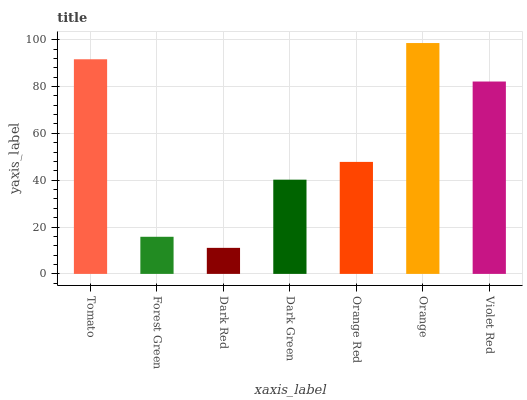Is Dark Red the minimum?
Answer yes or no. Yes. Is Orange the maximum?
Answer yes or no. Yes. Is Forest Green the minimum?
Answer yes or no. No. Is Forest Green the maximum?
Answer yes or no. No. Is Tomato greater than Forest Green?
Answer yes or no. Yes. Is Forest Green less than Tomato?
Answer yes or no. Yes. Is Forest Green greater than Tomato?
Answer yes or no. No. Is Tomato less than Forest Green?
Answer yes or no. No. Is Orange Red the high median?
Answer yes or no. Yes. Is Orange Red the low median?
Answer yes or no. Yes. Is Dark Red the high median?
Answer yes or no. No. Is Tomato the low median?
Answer yes or no. No. 